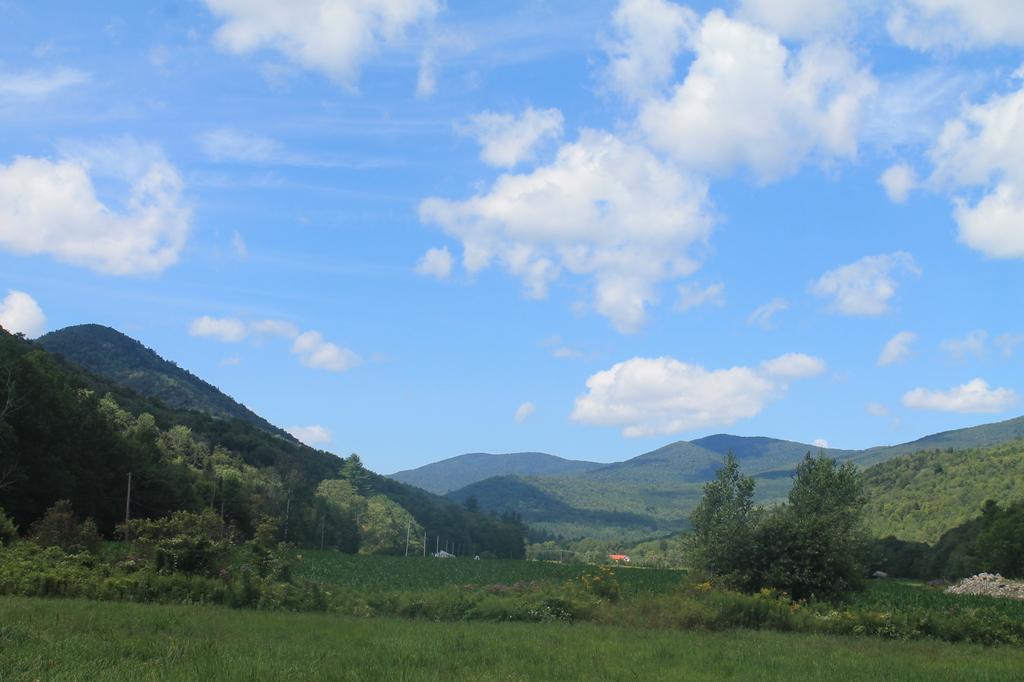Please provide a concise description of this image. In this image I can see the grass and many trees. In the background I can see the mountains, clouds and the sky. 